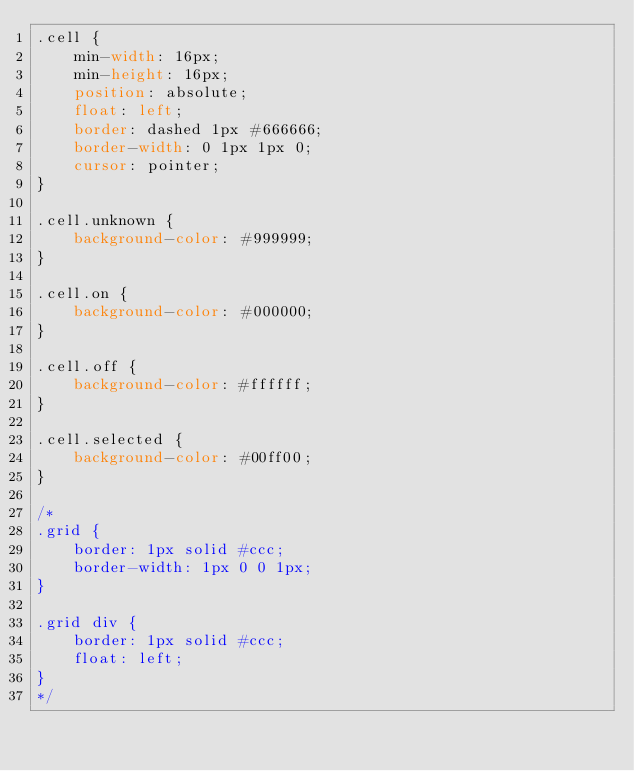Convert code to text. <code><loc_0><loc_0><loc_500><loc_500><_CSS_>.cell {
    min-width: 16px;
    min-height: 16px;
    position: absolute;
    float: left;
    border: dashed 1px #666666;
    border-width: 0 1px 1px 0;
    cursor: pointer;
}

.cell.unknown {
    background-color: #999999;
}

.cell.on {
    background-color: #000000;
}

.cell.off {
    background-color: #ffffff;
}

.cell.selected {
    background-color: #00ff00;
}

/*
.grid {
    border: 1px solid #ccc;
    border-width: 1px 0 0 1px;
}

.grid div {
    border: 1px solid #ccc;
    float: left;
}
*/
</code> 